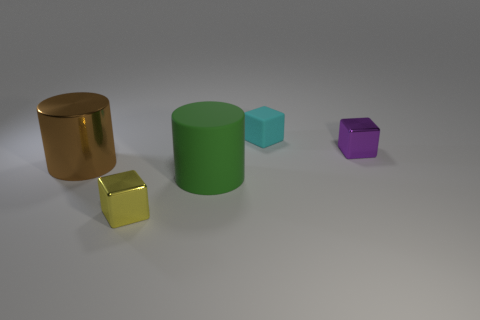Subtract all yellow blocks. How many blocks are left? 2 Add 2 red things. How many objects exist? 7 Subtract all brown cubes. Subtract all yellow balls. How many cubes are left? 3 Subtract all cubes. How many objects are left? 2 Add 5 yellow shiny things. How many yellow shiny things are left? 6 Add 3 large yellow cubes. How many large yellow cubes exist? 3 Subtract 0 cyan spheres. How many objects are left? 5 Subtract all green rubber cylinders. Subtract all big brown objects. How many objects are left? 3 